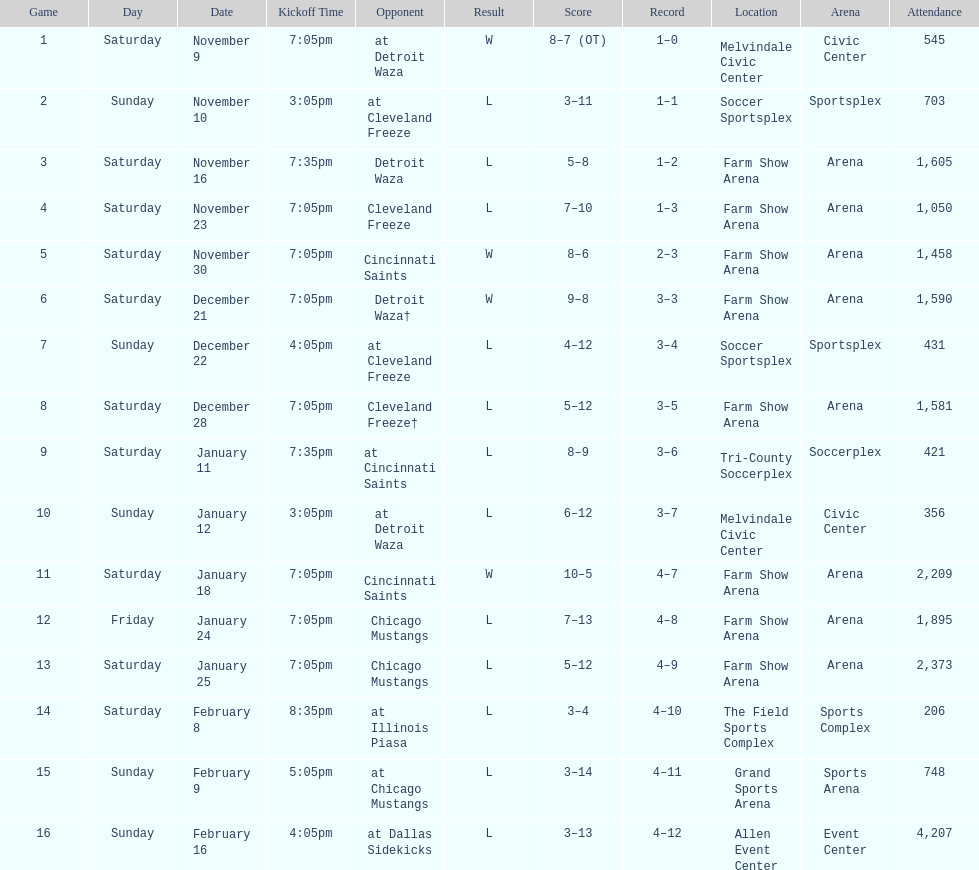What is the date of the game after december 22? December 28. 